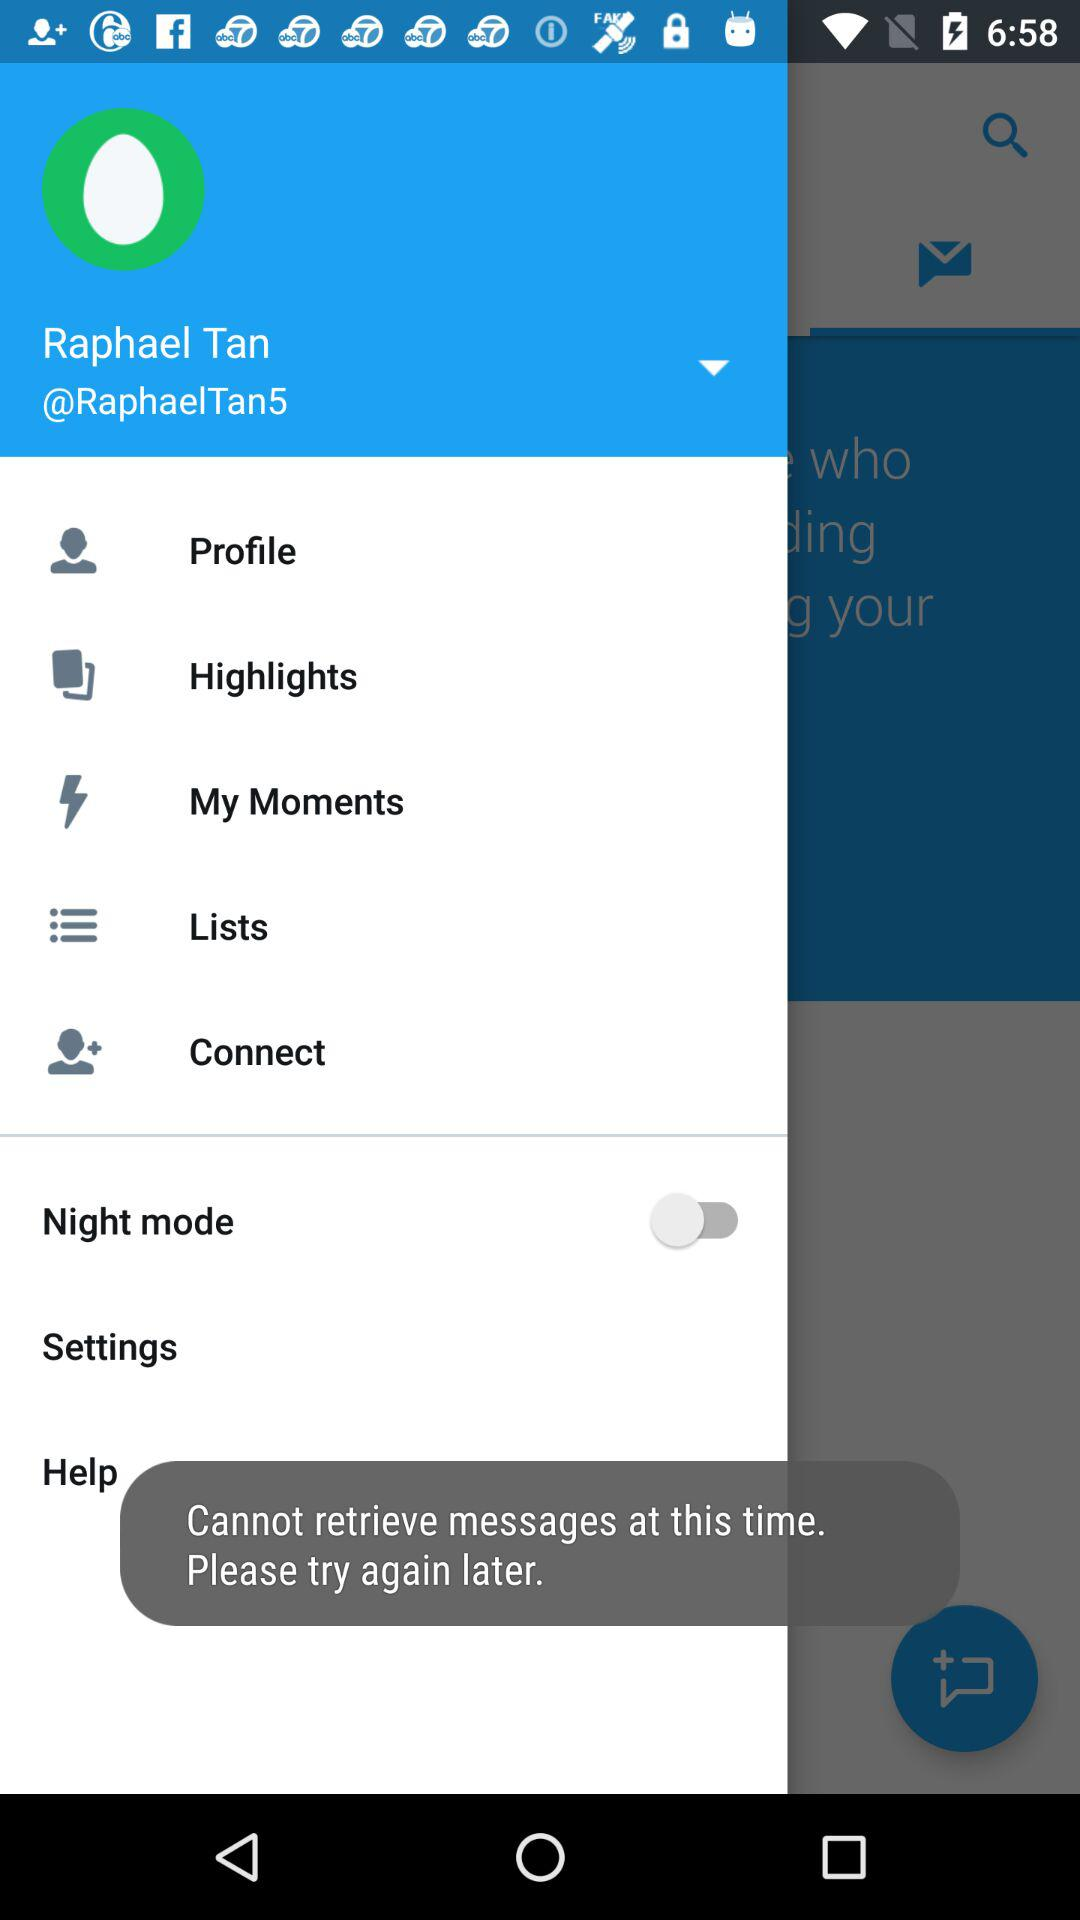What is the user name? The user name is Raphael Tan. 